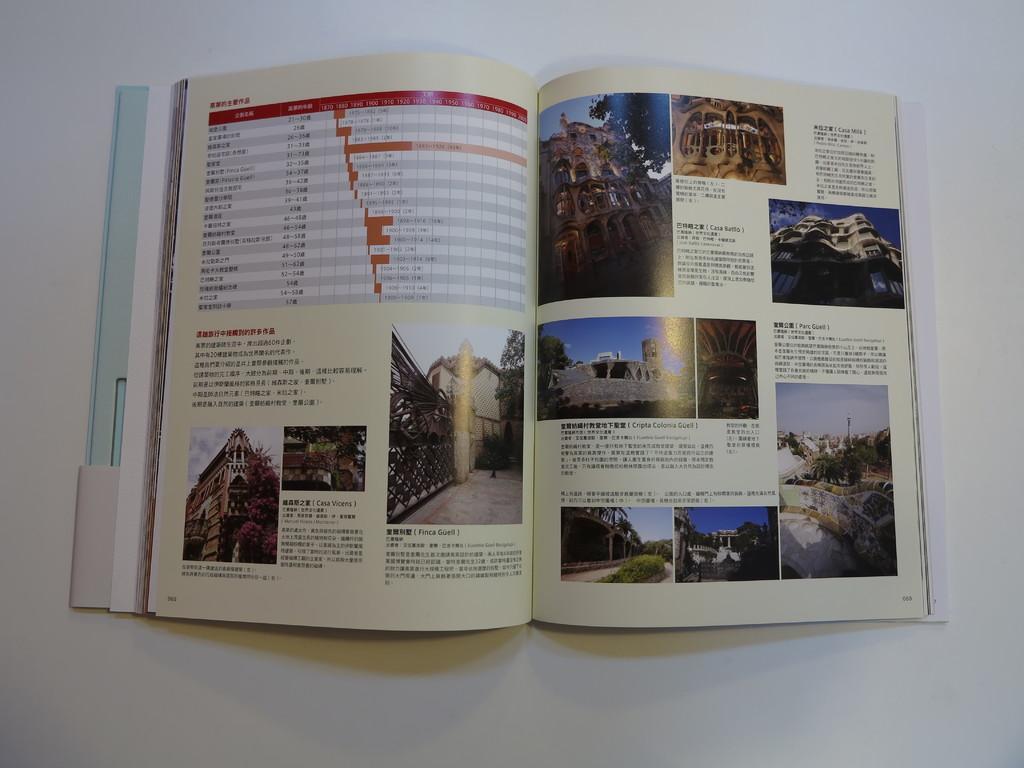Can you describe this image briefly? In this image we can see a book opened, and placed on the surface. 